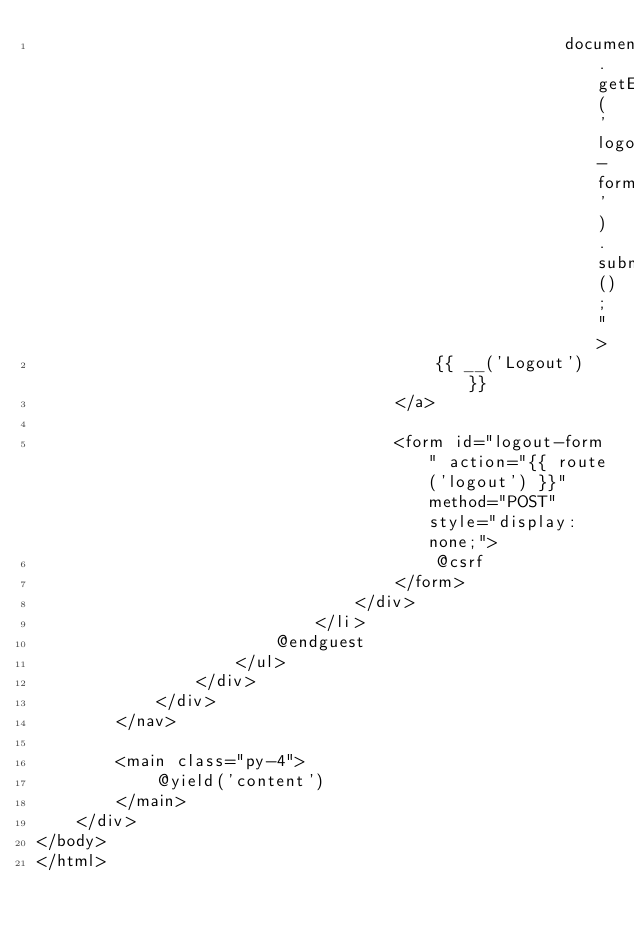Convert code to text. <code><loc_0><loc_0><loc_500><loc_500><_PHP_>                                                     document.getElementById('logout-form').submit();">
                                        {{ __('Logout') }}
                                    </a>

                                    <form id="logout-form" action="{{ route('logout') }}" method="POST" style="display: none;">
                                        @csrf
                                    </form>
                                </div>
                            </li>
                        @endguest
                    </ul>
                </div>
            </div>
        </nav>

        <main class="py-4">
            @yield('content')
        </main>
    </div>
</body>
</html>
</code> 